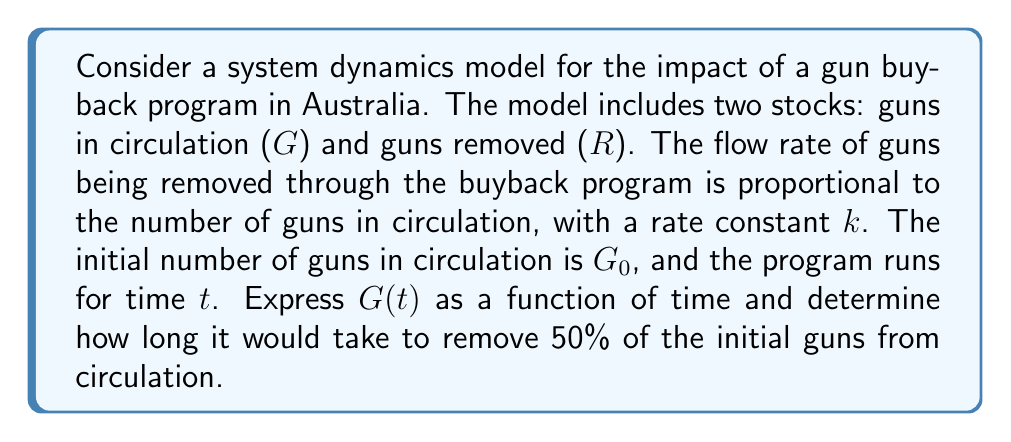Can you answer this question? To solve this problem, we'll use system dynamics equations and exponential decay principles:

1) The rate of change for guns in circulation is given by:
   $$\frac{dG}{dt} = -kG$$

2) This differential equation describes exponential decay, with the solution:
   $$G(t) = G_0e^{-kt}$$

3) To find the time when 50% of guns are removed, we set:
   $$G(t) = 0.5G_0$$

4) Substituting this into our solution:
   $$0.5G_0 = G_0e^{-kt}$$

5) Simplifying:
   $$0.5 = e^{-kt}$$

6) Taking the natural log of both sides:
   $$\ln(0.5) = -kt$$

7) Solving for $t$:
   $$t = -\frac{\ln(0.5)}{k} = \frac{\ln(2)}{k}$$

This result shows that the time to remove 50% of guns is inversely proportional to the rate constant $k$. A higher $k$ value (more efficient buyback program) will result in a shorter time to reach the 50% reduction goal.
Answer: The time to remove 50% of guns from circulation is $t = \frac{\ln(2)}{k}$, where $k$ is the rate constant of the buyback program. 